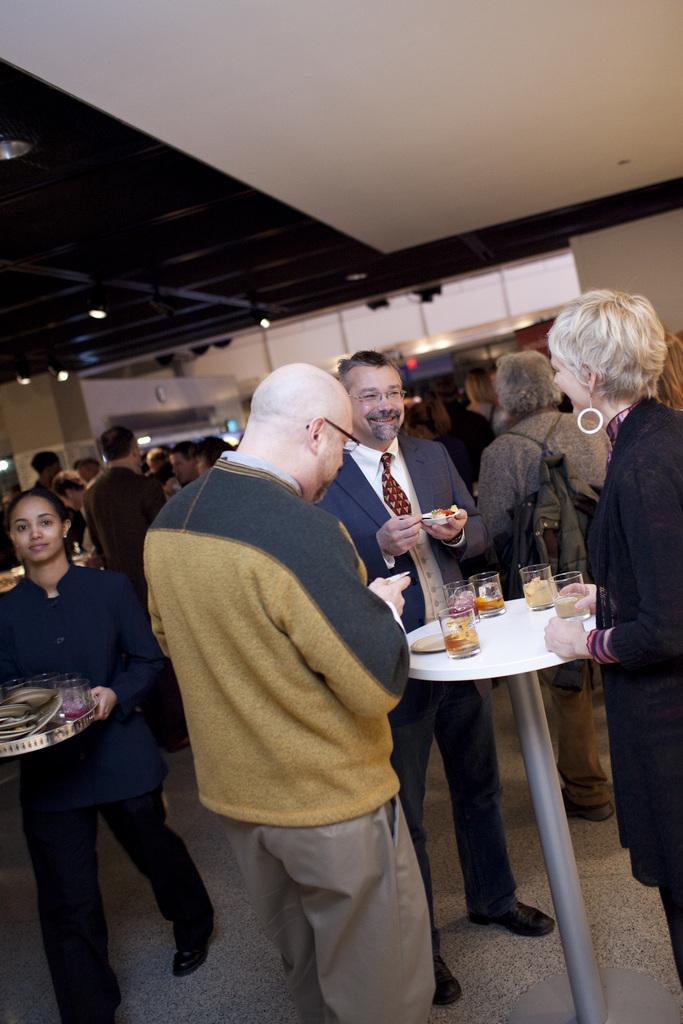Can you describe this image briefly? In this picture there are people and we can see glasses and plate on the table. In the background of the image we can see lights and wall. 